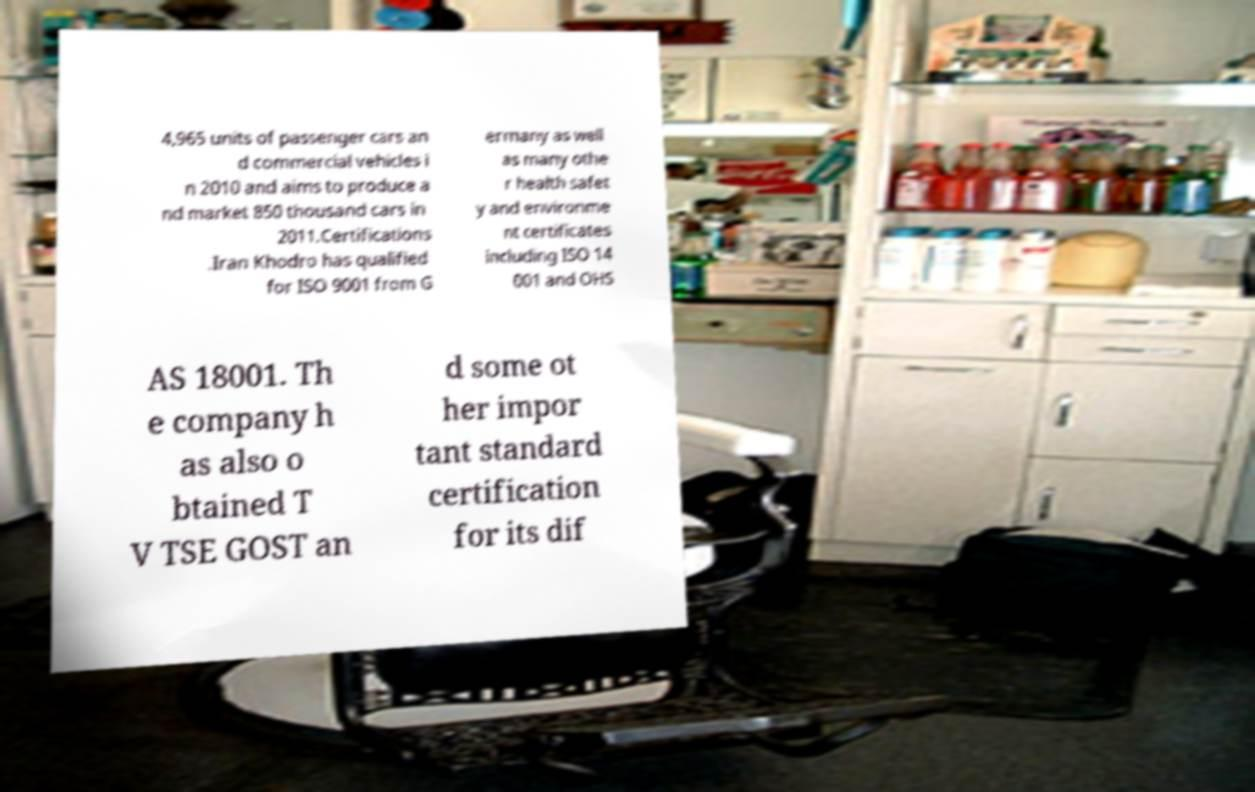For documentation purposes, I need the text within this image transcribed. Could you provide that? 4,965 units of passenger cars an d commercial vehicles i n 2010 and aims to produce a nd market 850 thousand cars in 2011.Certifications .Iran Khodro has qualified for ISO 9001 from G ermany as well as many othe r health safet y and environme nt certificates including ISO 14 001 and OHS AS 18001. Th e company h as also o btained T V TSE GOST an d some ot her impor tant standard certification for its dif 